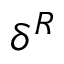Convert formula to latex. <formula><loc_0><loc_0><loc_500><loc_500>\delta ^ { R }</formula> 